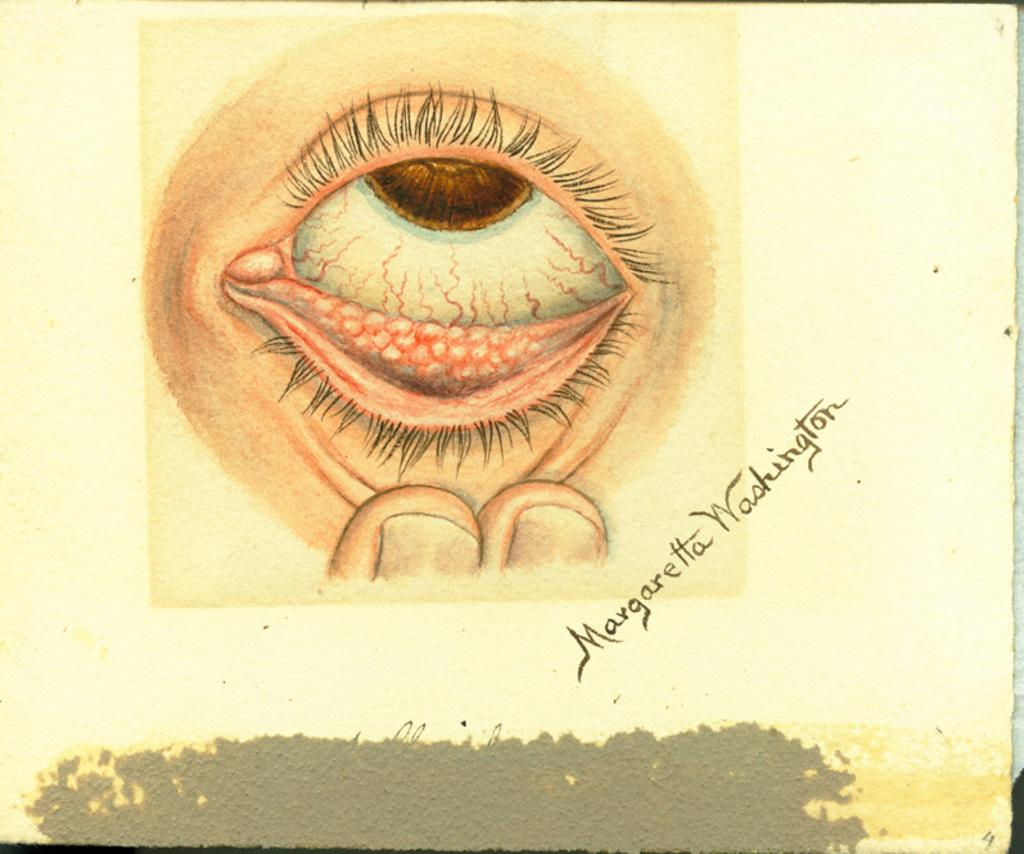What is present on the table in the image? There is a poster on the table in the image. What is depicted on the poster? The poster contains an image of a person's eye and fingers. Is there any text on the poster? Yes, the person's name is visible on the poster. How many nerves can be seen in the image? There are no nerves visible in the image; it features a poster with an image of a person's eye and fingers. 